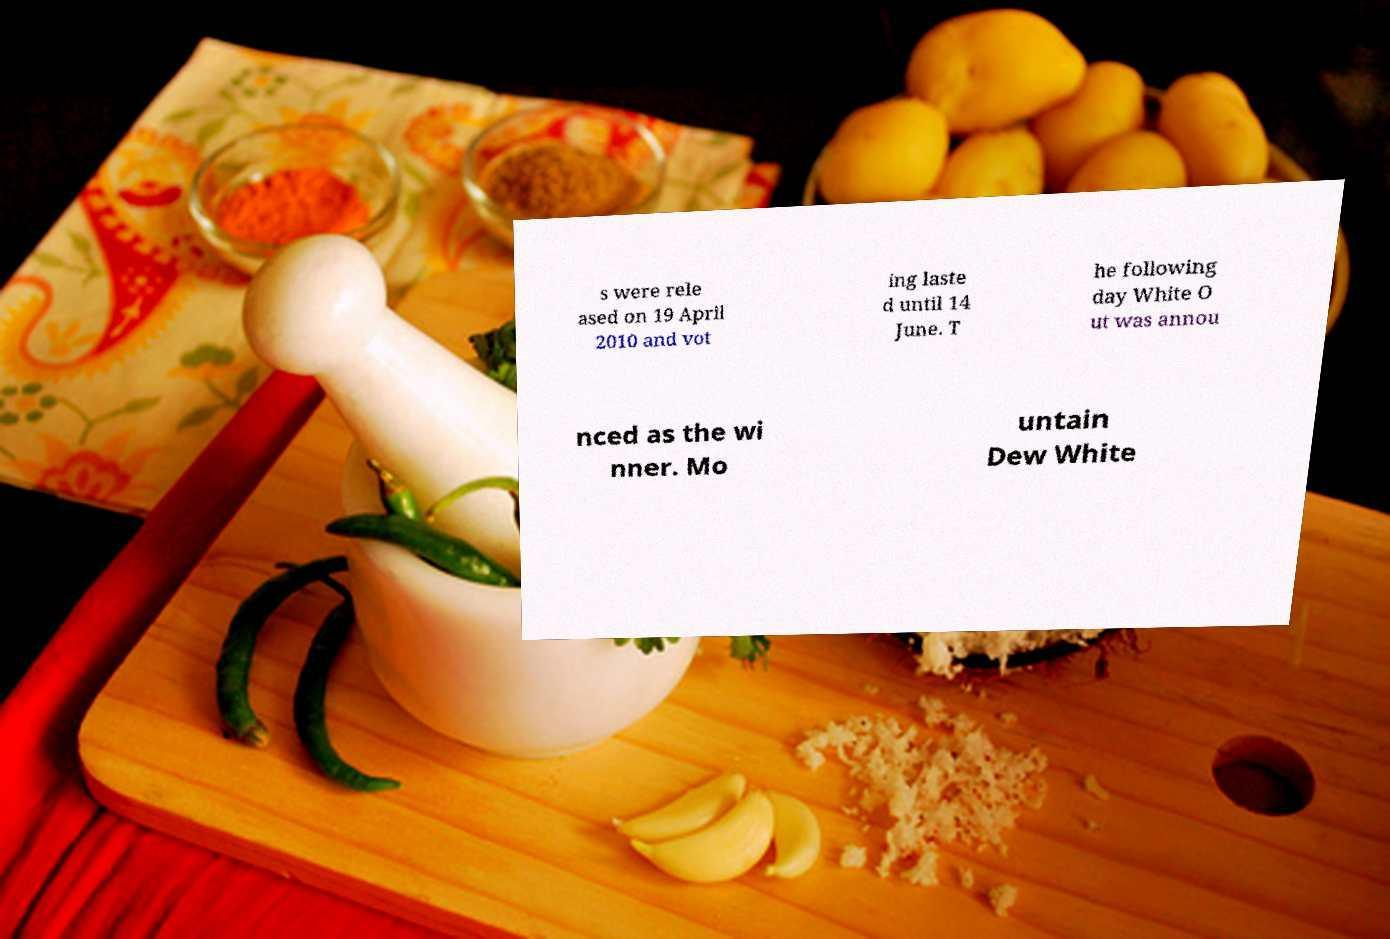There's text embedded in this image that I need extracted. Can you transcribe it verbatim? s were rele ased on 19 April 2010 and vot ing laste d until 14 June. T he following day White O ut was annou nced as the wi nner. Mo untain Dew White 